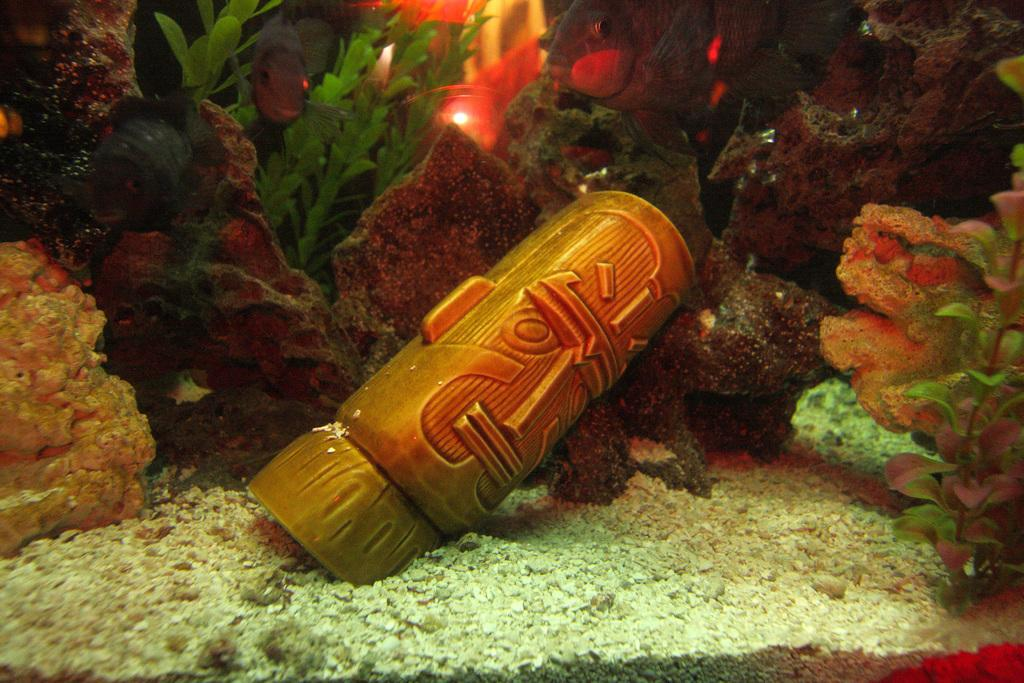What type of natural elements can be seen in the image? There are stones and plants in the image. Can you describe the light source visible in the background of the image? There is a light visible in the background of the image. What type of grape is growing on the plants in the image? There are no grapes present in the image; only stones and plants can be seen. 